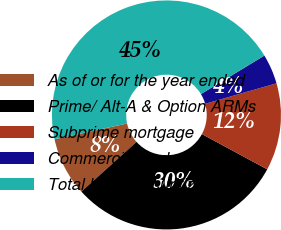Convert chart. <chart><loc_0><loc_0><loc_500><loc_500><pie_chart><fcel>As of or for the year ended<fcel>Prime/ Alt-A & Option ARMs<fcel>Subprime mortgage<fcel>Commercial and other<fcel>Total loans securitized (b)<nl><fcel>8.27%<fcel>30.45%<fcel>12.33%<fcel>4.22%<fcel>44.73%<nl></chart> 